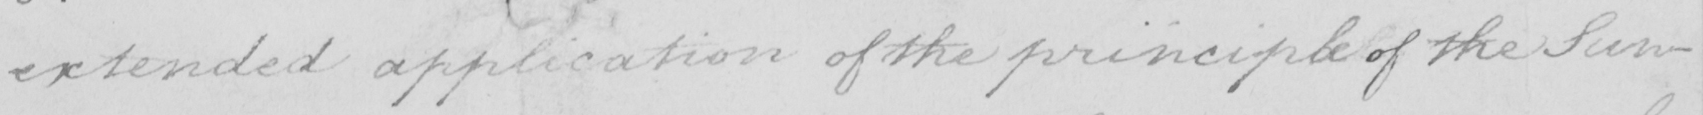What is written in this line of handwriting? extended application of the principle of the Sun- 